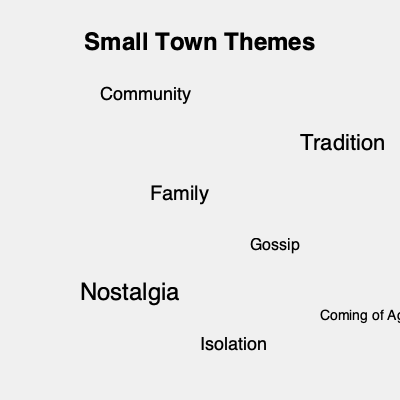As a novelist writing about your experiences in a small town, how would you use this word cloud to enhance the thematic depth of your novel? Discuss two specific themes and explain how you would incorporate them into your narrative structure. To answer this question, follow these steps:

1. Analyze the word cloud:
   The word cloud presents several themes common in small town narratives: Community, Tradition, Family, Gossip, Nostalgia, Coming of Age, and Isolation.

2. Select two themes:
   For this example, let's choose "Nostalgia" and "Isolation."

3. Incorporate "Nostalgia" into the narrative structure:
   - Use flashbacks to contrast past and present
   - Describe changes in the town over time
   - Create characters who embody or resist nostalgic feelings
   - Use sensory details to evoke memories

4. Incorporate "Isolation" into the narrative structure:
   - Develop a protagonist who feels different from the community
   - Describe physical isolation of the town
   - Explore emotional isolation within families or social groups
   - Use weather or landscape as a metaphor for isolation

5. Integrate these themes:
   - Show how nostalgia can both comfort and isolate characters
   - Contrast communal nostalgia with individual isolation
   - Demonstrate how isolation can lead to a nostalgic view of the past

By weaving these themes throughout the novel, you can create a rich, layered narrative that explores the complexities of small town life.
Answer: Incorporate "Nostalgia" through flashbacks and sensory details; integrate "Isolation" by developing a protagonist who feels different and using landscape metaphors. Intertwine themes to show how nostalgia and isolation affect characters' perceptions and relationships in the small town setting. 